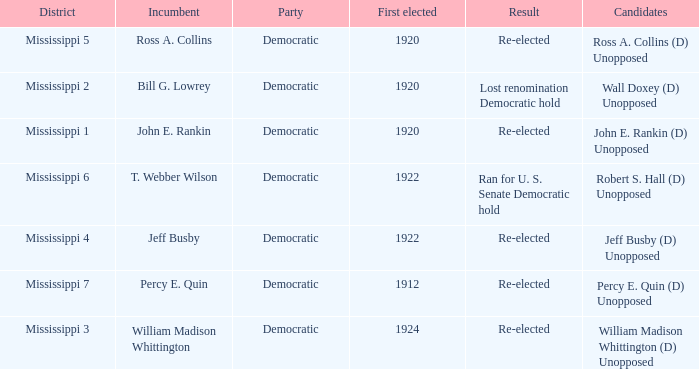What was the result of the election featuring william madison whittington? Re-elected. 